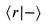<formula> <loc_0><loc_0><loc_500><loc_500>\langle r | - \rangle</formula> 